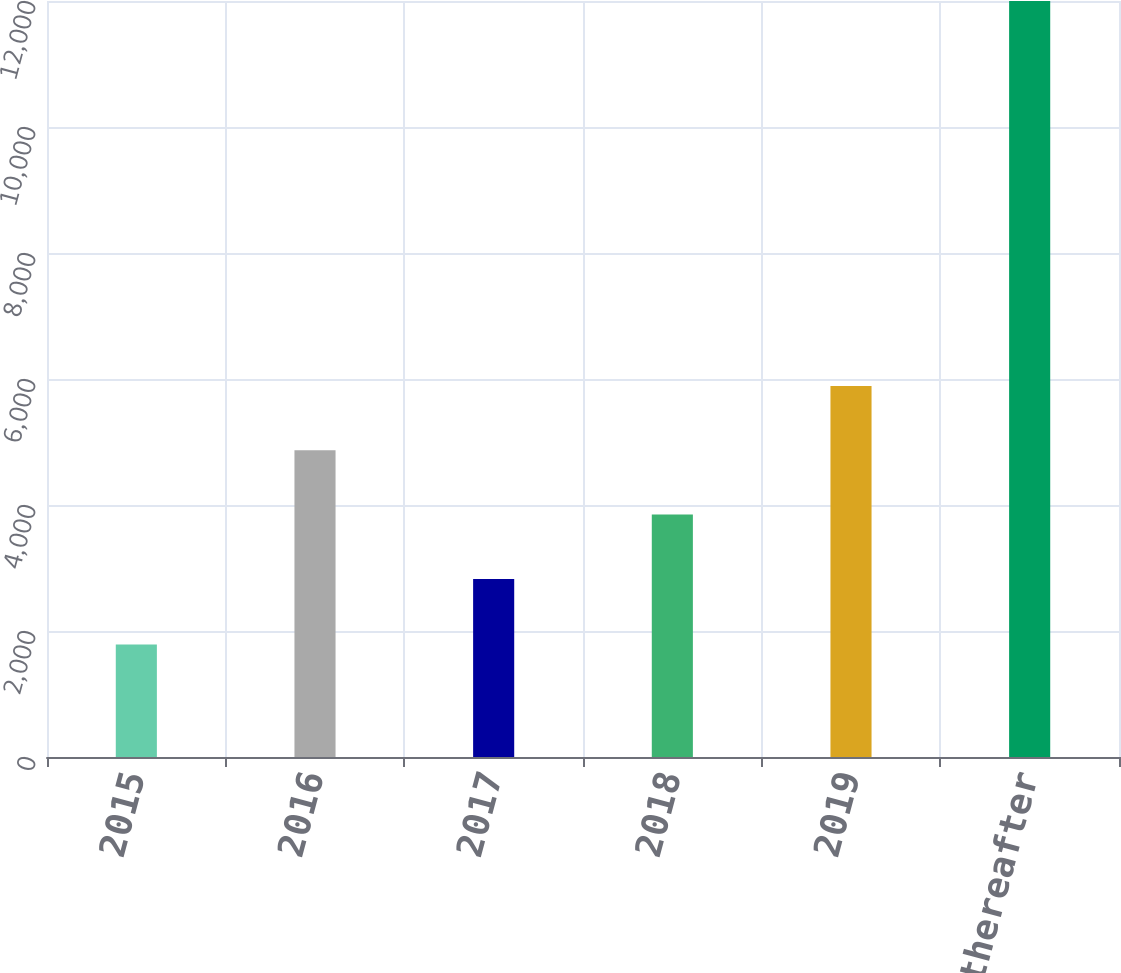<chart> <loc_0><loc_0><loc_500><loc_500><bar_chart><fcel>2015<fcel>2016<fcel>2017<fcel>2018<fcel>2019<fcel>2020 and thereafter<nl><fcel>1785<fcel>4868.8<fcel>2826<fcel>3847.4<fcel>5890.2<fcel>11999<nl></chart> 